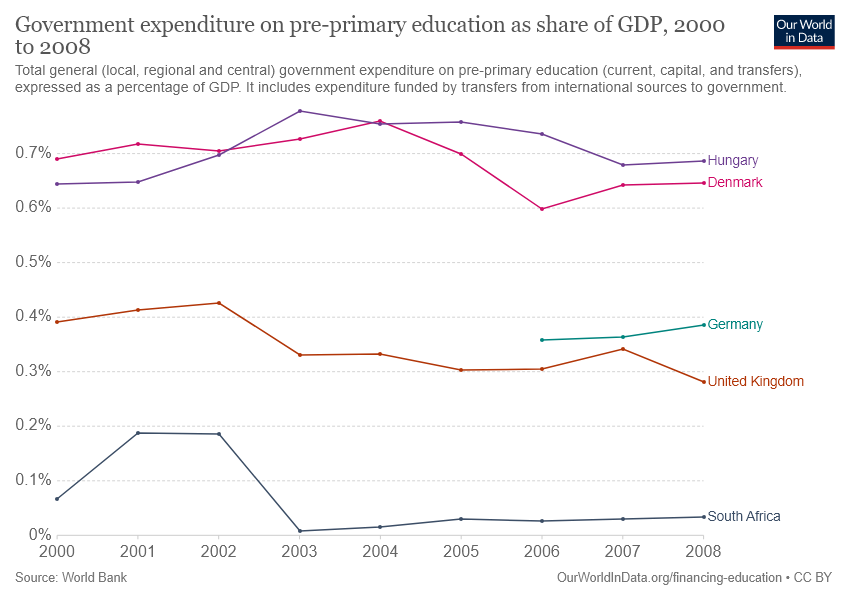Point out several critical features in this image. The Red Line bar is located in Denmark. The graph showing the share of energy from renewable sources in the total energy consumption of two countries never crossed 0.4%. Germany and South Africa were among the countries that did not reach this threshold. 